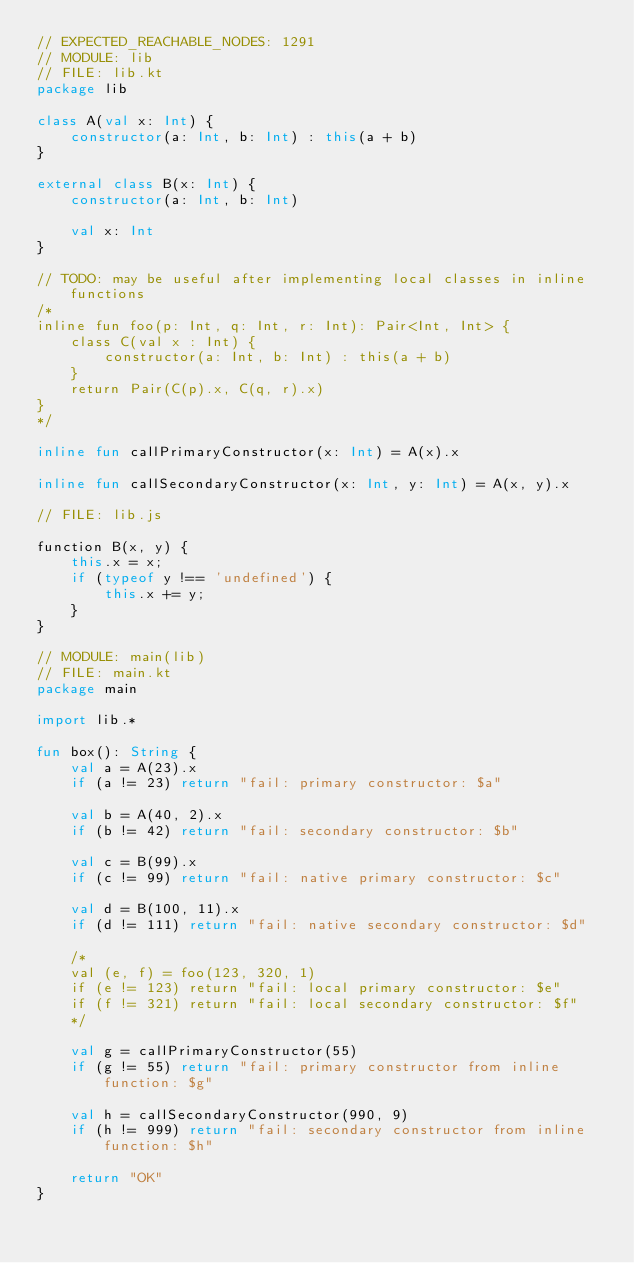Convert code to text. <code><loc_0><loc_0><loc_500><loc_500><_Kotlin_>// EXPECTED_REACHABLE_NODES: 1291
// MODULE: lib
// FILE: lib.kt
package lib

class A(val x: Int) {
    constructor(a: Int, b: Int) : this(a + b)
}

external class B(x: Int) {
    constructor(a: Int, b: Int)

    val x: Int
}

// TODO: may be useful after implementing local classes in inline functions
/*
inline fun foo(p: Int, q: Int, r: Int): Pair<Int, Int> {
    class C(val x : Int) {
        constructor(a: Int, b: Int) : this(a + b)
    }
    return Pair(C(p).x, C(q, r).x)
}
*/

inline fun callPrimaryConstructor(x: Int) = A(x).x

inline fun callSecondaryConstructor(x: Int, y: Int) = A(x, y).x

// FILE: lib.js

function B(x, y) {
    this.x = x;
    if (typeof y !== 'undefined') {
        this.x += y;
    }
}

// MODULE: main(lib)
// FILE: main.kt
package main

import lib.*

fun box(): String {
    val a = A(23).x
    if (a != 23) return "fail: primary constructor: $a"

    val b = A(40, 2).x
    if (b != 42) return "fail: secondary constructor: $b"

    val c = B(99).x
    if (c != 99) return "fail: native primary constructor: $c"

    val d = B(100, 11).x
    if (d != 111) return "fail: native secondary constructor: $d"

    /*
    val (e, f) = foo(123, 320, 1)
    if (e != 123) return "fail: local primary constructor: $e"
    if (f != 321) return "fail: local secondary constructor: $f"
    */

    val g = callPrimaryConstructor(55)
    if (g != 55) return "fail: primary constructor from inline function: $g"

    val h = callSecondaryConstructor(990, 9)
    if (h != 999) return "fail: secondary constructor from inline function: $h"

    return "OK"
}</code> 